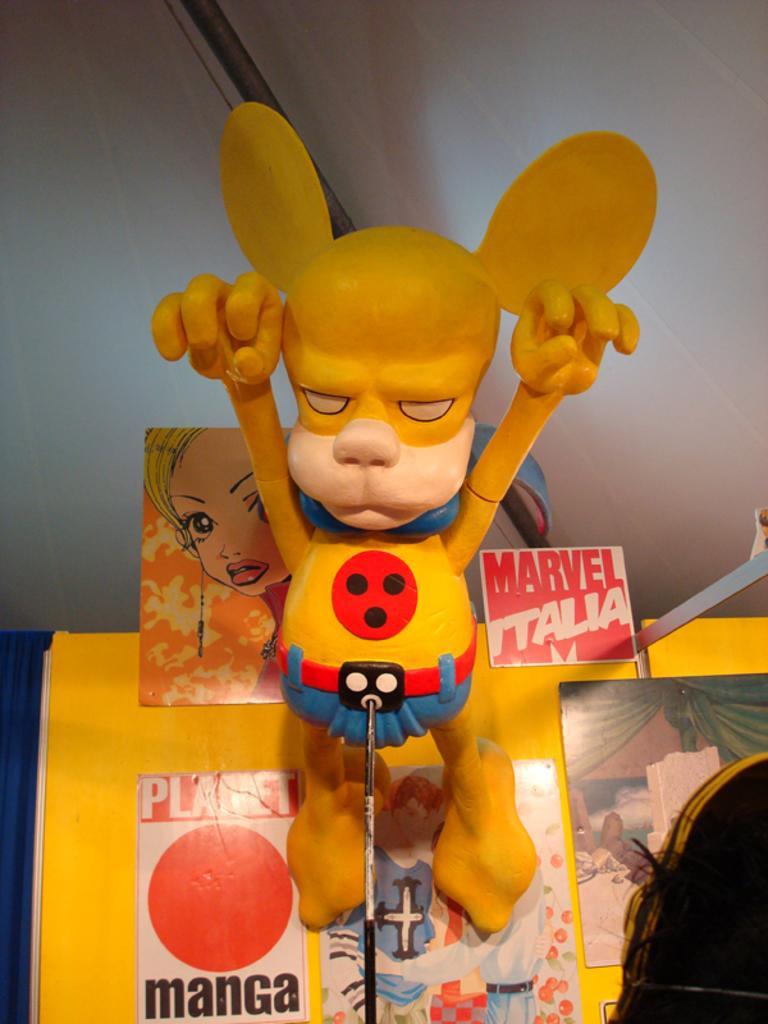In one or two sentences, can you explain what this image depicts? In this picture we can see a toy with the stand and behind the toys there are boards, wall, rod and other things. 